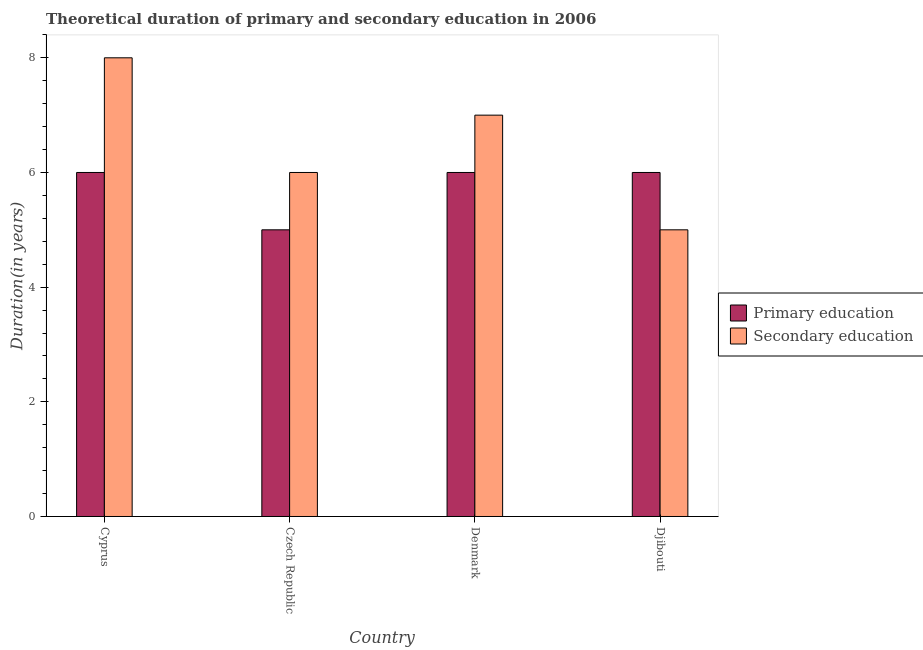How many groups of bars are there?
Offer a terse response. 4. Are the number of bars on each tick of the X-axis equal?
Offer a terse response. Yes. How many bars are there on the 1st tick from the right?
Offer a terse response. 2. What is the label of the 2nd group of bars from the left?
Offer a terse response. Czech Republic. In how many cases, is the number of bars for a given country not equal to the number of legend labels?
Offer a terse response. 0. What is the duration of secondary education in Czech Republic?
Make the answer very short. 6. Across all countries, what is the minimum duration of secondary education?
Offer a very short reply. 5. In which country was the duration of secondary education maximum?
Ensure brevity in your answer.  Cyprus. In which country was the duration of primary education minimum?
Keep it short and to the point. Czech Republic. What is the total duration of secondary education in the graph?
Provide a succinct answer. 26. What is the difference between the duration of secondary education in Cyprus and that in Denmark?
Keep it short and to the point. 1. What is the difference between the duration of secondary education in Denmark and the duration of primary education in Czech Republic?
Keep it short and to the point. 2. What is the average duration of primary education per country?
Ensure brevity in your answer.  5.75. What is the difference between the duration of secondary education and duration of primary education in Cyprus?
Your response must be concise. 2. In how many countries, is the duration of primary education greater than 5.2 years?
Provide a succinct answer. 3. What is the difference between the highest and the second highest duration of primary education?
Provide a short and direct response. 0. What is the difference between the highest and the lowest duration of secondary education?
Your answer should be very brief. 3. In how many countries, is the duration of secondary education greater than the average duration of secondary education taken over all countries?
Make the answer very short. 2. What does the 1st bar from the left in Cyprus represents?
Ensure brevity in your answer.  Primary education. How many bars are there?
Offer a very short reply. 8. How many countries are there in the graph?
Offer a terse response. 4. Does the graph contain any zero values?
Make the answer very short. No. Does the graph contain grids?
Make the answer very short. No. Where does the legend appear in the graph?
Ensure brevity in your answer.  Center right. How are the legend labels stacked?
Your answer should be compact. Vertical. What is the title of the graph?
Your answer should be compact. Theoretical duration of primary and secondary education in 2006. What is the label or title of the X-axis?
Provide a short and direct response. Country. What is the label or title of the Y-axis?
Your answer should be very brief. Duration(in years). What is the Duration(in years) in Primary education in Cyprus?
Offer a terse response. 6. What is the Duration(in years) in Primary education in Czech Republic?
Your response must be concise. 5. What is the Duration(in years) of Secondary education in Czech Republic?
Provide a short and direct response. 6. What is the Duration(in years) in Primary education in Denmark?
Your answer should be very brief. 6. What is the Duration(in years) of Secondary education in Denmark?
Your answer should be very brief. 7. Across all countries, what is the maximum Duration(in years) of Primary education?
Make the answer very short. 6. Across all countries, what is the minimum Duration(in years) of Primary education?
Make the answer very short. 5. What is the total Duration(in years) in Primary education in the graph?
Your answer should be very brief. 23. What is the total Duration(in years) in Secondary education in the graph?
Provide a short and direct response. 26. What is the difference between the Duration(in years) in Primary education in Cyprus and that in Czech Republic?
Offer a terse response. 1. What is the difference between the Duration(in years) of Secondary education in Cyprus and that in Czech Republic?
Offer a very short reply. 2. What is the difference between the Duration(in years) of Primary education in Czech Republic and that in Denmark?
Your response must be concise. -1. What is the difference between the Duration(in years) of Secondary education in Czech Republic and that in Djibouti?
Your answer should be compact. 1. What is the difference between the Duration(in years) in Secondary education in Denmark and that in Djibouti?
Provide a short and direct response. 2. What is the difference between the Duration(in years) of Primary education in Czech Republic and the Duration(in years) of Secondary education in Denmark?
Your answer should be compact. -2. What is the difference between the Duration(in years) in Primary education in Czech Republic and the Duration(in years) in Secondary education in Djibouti?
Offer a very short reply. 0. What is the difference between the Duration(in years) in Primary education in Denmark and the Duration(in years) in Secondary education in Djibouti?
Ensure brevity in your answer.  1. What is the average Duration(in years) in Primary education per country?
Make the answer very short. 5.75. What is the difference between the Duration(in years) of Primary education and Duration(in years) of Secondary education in Djibouti?
Give a very brief answer. 1. What is the ratio of the Duration(in years) of Secondary education in Cyprus to that in Czech Republic?
Keep it short and to the point. 1.33. What is the ratio of the Duration(in years) of Secondary education in Cyprus to that in Djibouti?
Your answer should be compact. 1.6. What is the ratio of the Duration(in years) in Secondary education in Czech Republic to that in Denmark?
Make the answer very short. 0.86. What is the ratio of the Duration(in years) of Primary education in Czech Republic to that in Djibouti?
Offer a terse response. 0.83. What is the ratio of the Duration(in years) in Secondary education in Czech Republic to that in Djibouti?
Provide a short and direct response. 1.2. What is the ratio of the Duration(in years) of Primary education in Denmark to that in Djibouti?
Make the answer very short. 1. What is the ratio of the Duration(in years) in Secondary education in Denmark to that in Djibouti?
Your answer should be very brief. 1.4. What is the difference between the highest and the second highest Duration(in years) in Primary education?
Offer a very short reply. 0. What is the difference between the highest and the lowest Duration(in years) in Primary education?
Make the answer very short. 1. 